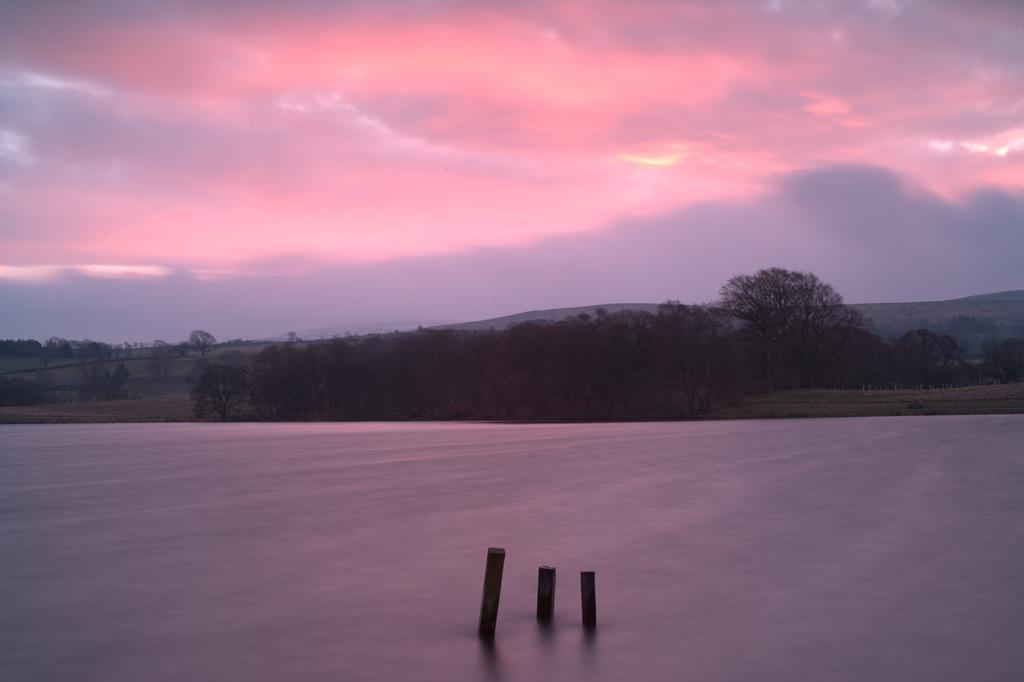Describe this image in one or two sentences. There is water. In the water there are three poles. In the background there are trees, hills and sky with red and gray color. 